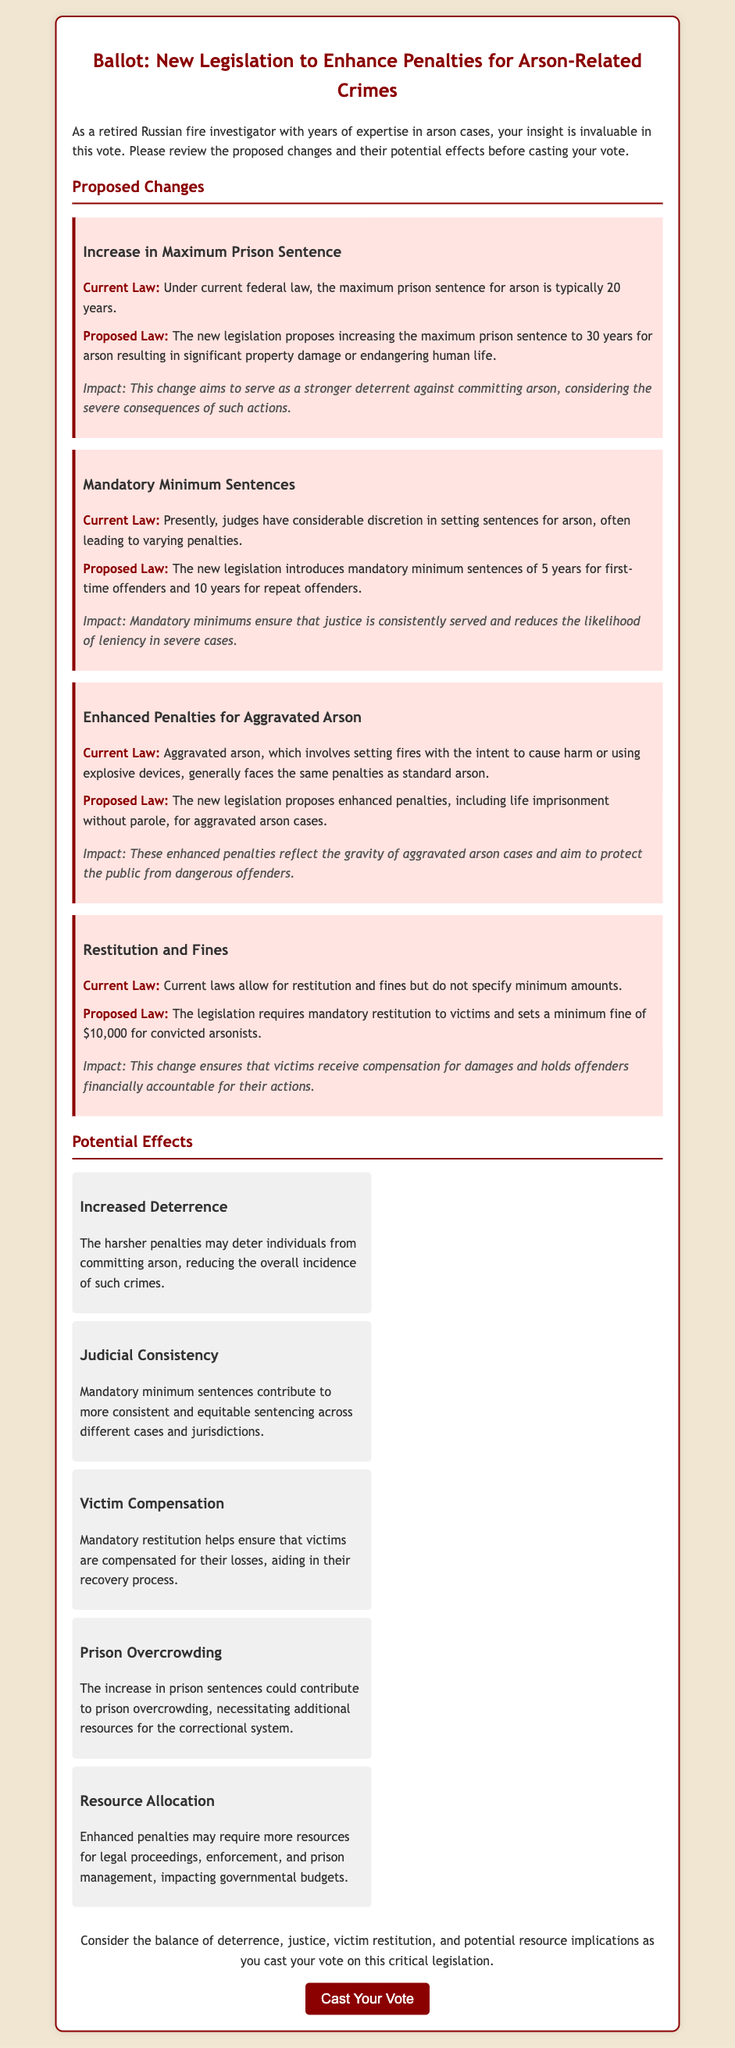What is the maximum prison sentence under current law for arson? The current federal law allows for a maximum prison sentence of 20 years for arson.
Answer: 20 years What is the proposed maximum prison sentence for arson? The proposal suggests increasing the maximum prison sentence to 30 years for arson resulting in significant property damage or endangering human life.
Answer: 30 years What is the mandatory minimum sentence for first-time offenders? The new legislation introduces a mandatory minimum sentence of 5 years for first-time offenders.
Answer: 5 years What is the proposed minimum fine for convicted arsonists? The legislation sets a minimum fine of $10,000 for convicted arsonists.
Answer: $10,000 What type of crime involves enhanced penalties according to the proposed law? The proposed law suggests enhanced penalties for aggravated arson cases.
Answer: Aggravated arson What is the potential effect of increased prison sentences mentioned in the document? Increased prison sentences could contribute to prison overcrowding, according to the potential effects listed.
Answer: Prison overcrowding How does the proposed legislation aim to ensure victim compensation? The legislation requires mandatory restitution to victims of arson, ensuring they receive compensation for damages.
Answer: Mandatory restitution What is one effect of mandatory minimum sentences stated in the document? Mandatory minimum sentences contribute to more consistent and equitable sentencing across different cases and jurisdictions.
Answer: Judicial consistency 